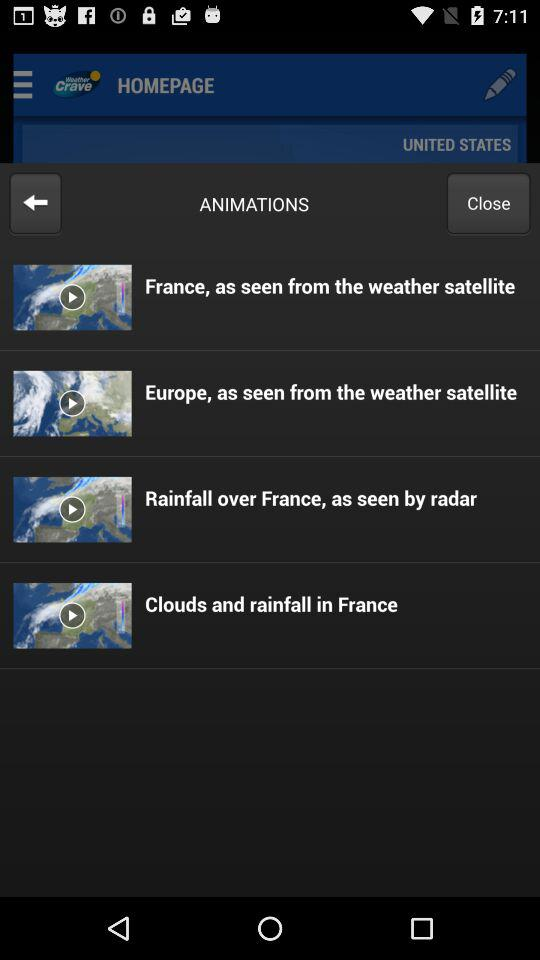What is the mentioned location? The mentioned location is the United States. 